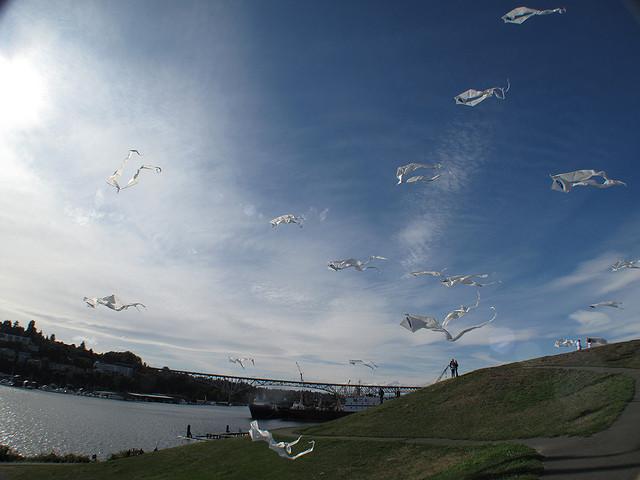What is in the sky?
Answer briefly. Kites. Is the sun shining clearly?
Write a very short answer. Yes. Is there a boat on the water?
Give a very brief answer. Yes. Is it cold?
Concise answer only. No. Is there snow on the ground?
Concise answer only. No. Is there water coming from the hydrant?
Quick response, please. No. What is floating in the sky?
Write a very short answer. Kites. How many kites are in the sky?
Write a very short answer. 15. Is the water a tropical blue?
Write a very short answer. No. The ground is made of what?
Short answer required. Grass. Is this a ocean?
Short answer required. No. 